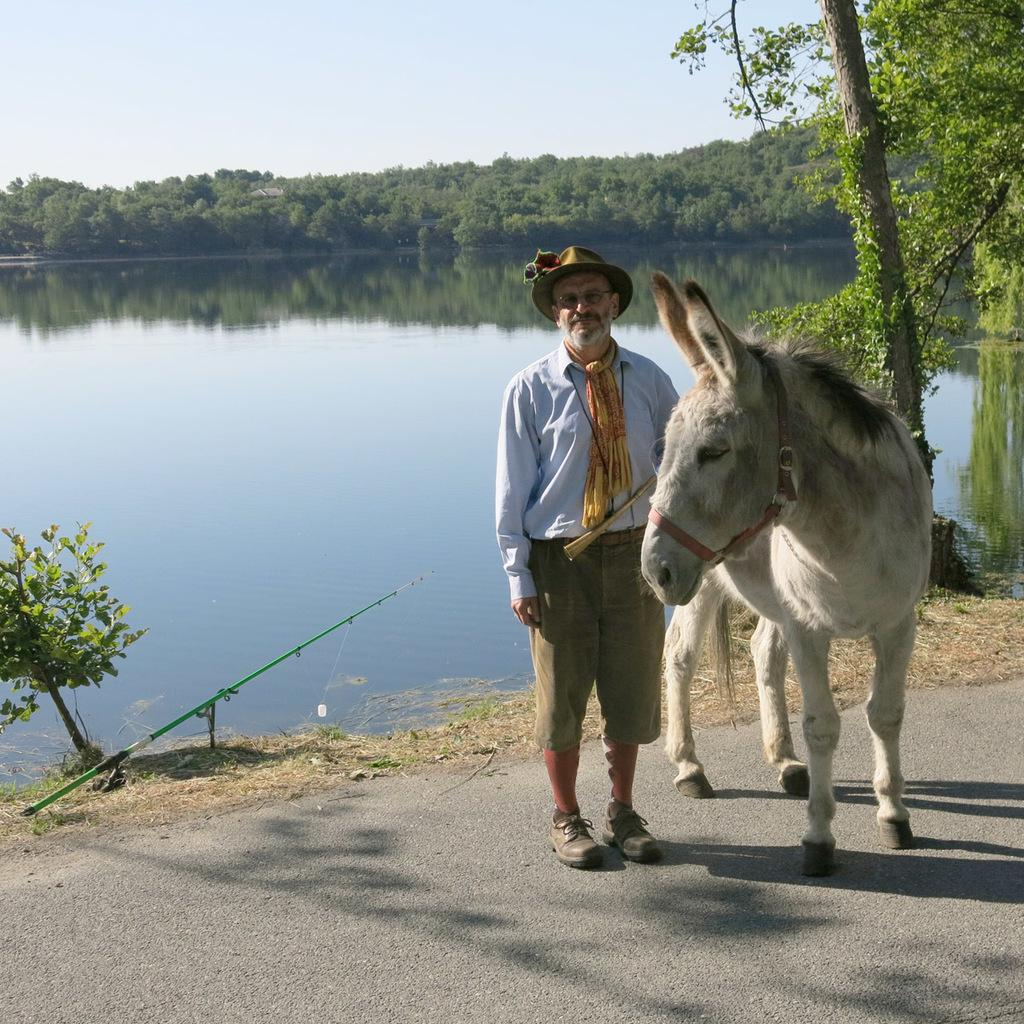What animal can be seen in the image? There is a horse in the image. What is the man in the image doing? The man is standing on the road and holding a fishing rod. What can be seen in the background of the image? The sky is visible in the background of the image. What type of clothing is the man wearing on his head? The man is wearing a cap. What type of eyewear is the man wearing? The man is wearing spectacles. What type of footwear is the man wearing? The man is wearing shoes. What type of vegetation is present in the image? There are trees in the image. What type of stick is the man using to reason with the horse in the image? There is no stick present in the image, and the man is not using any object to reason with the horse. 